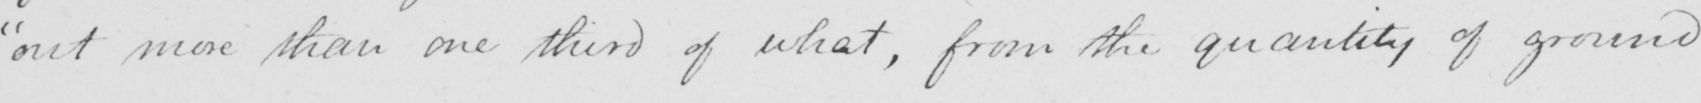Can you tell me what this handwritten text says? out more than one third of what , from the quantity of ground 